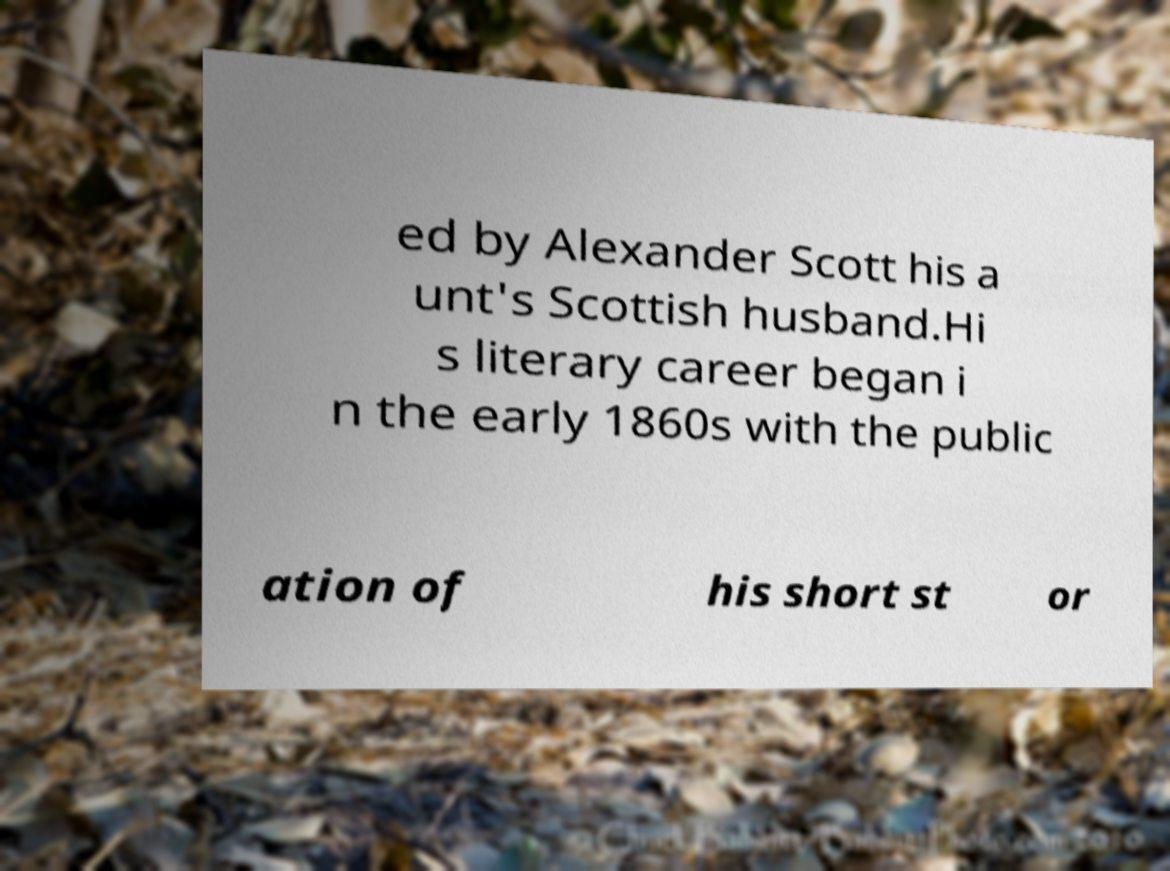Could you assist in decoding the text presented in this image and type it out clearly? ed by Alexander Scott his a unt's Scottish husband.Hi s literary career began i n the early 1860s with the public ation of his short st or 